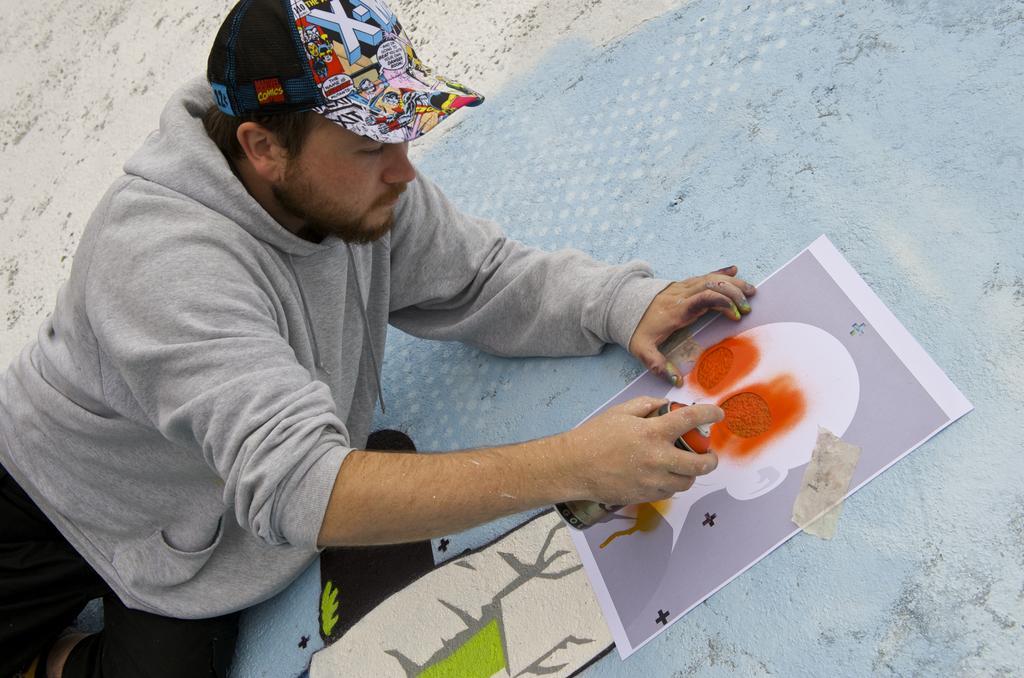Please provide a concise description of this image. In this image, we can see a person wearing a cap and holding a graffiti bottle. In the background, there is a wall and we can see a paper and there is graffiti. 